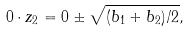<formula> <loc_0><loc_0><loc_500><loc_500>0 \cdot z _ { 2 } = 0 \pm \sqrt { ( b _ { 1 } + b _ { 2 } ) / 2 } ,</formula> 